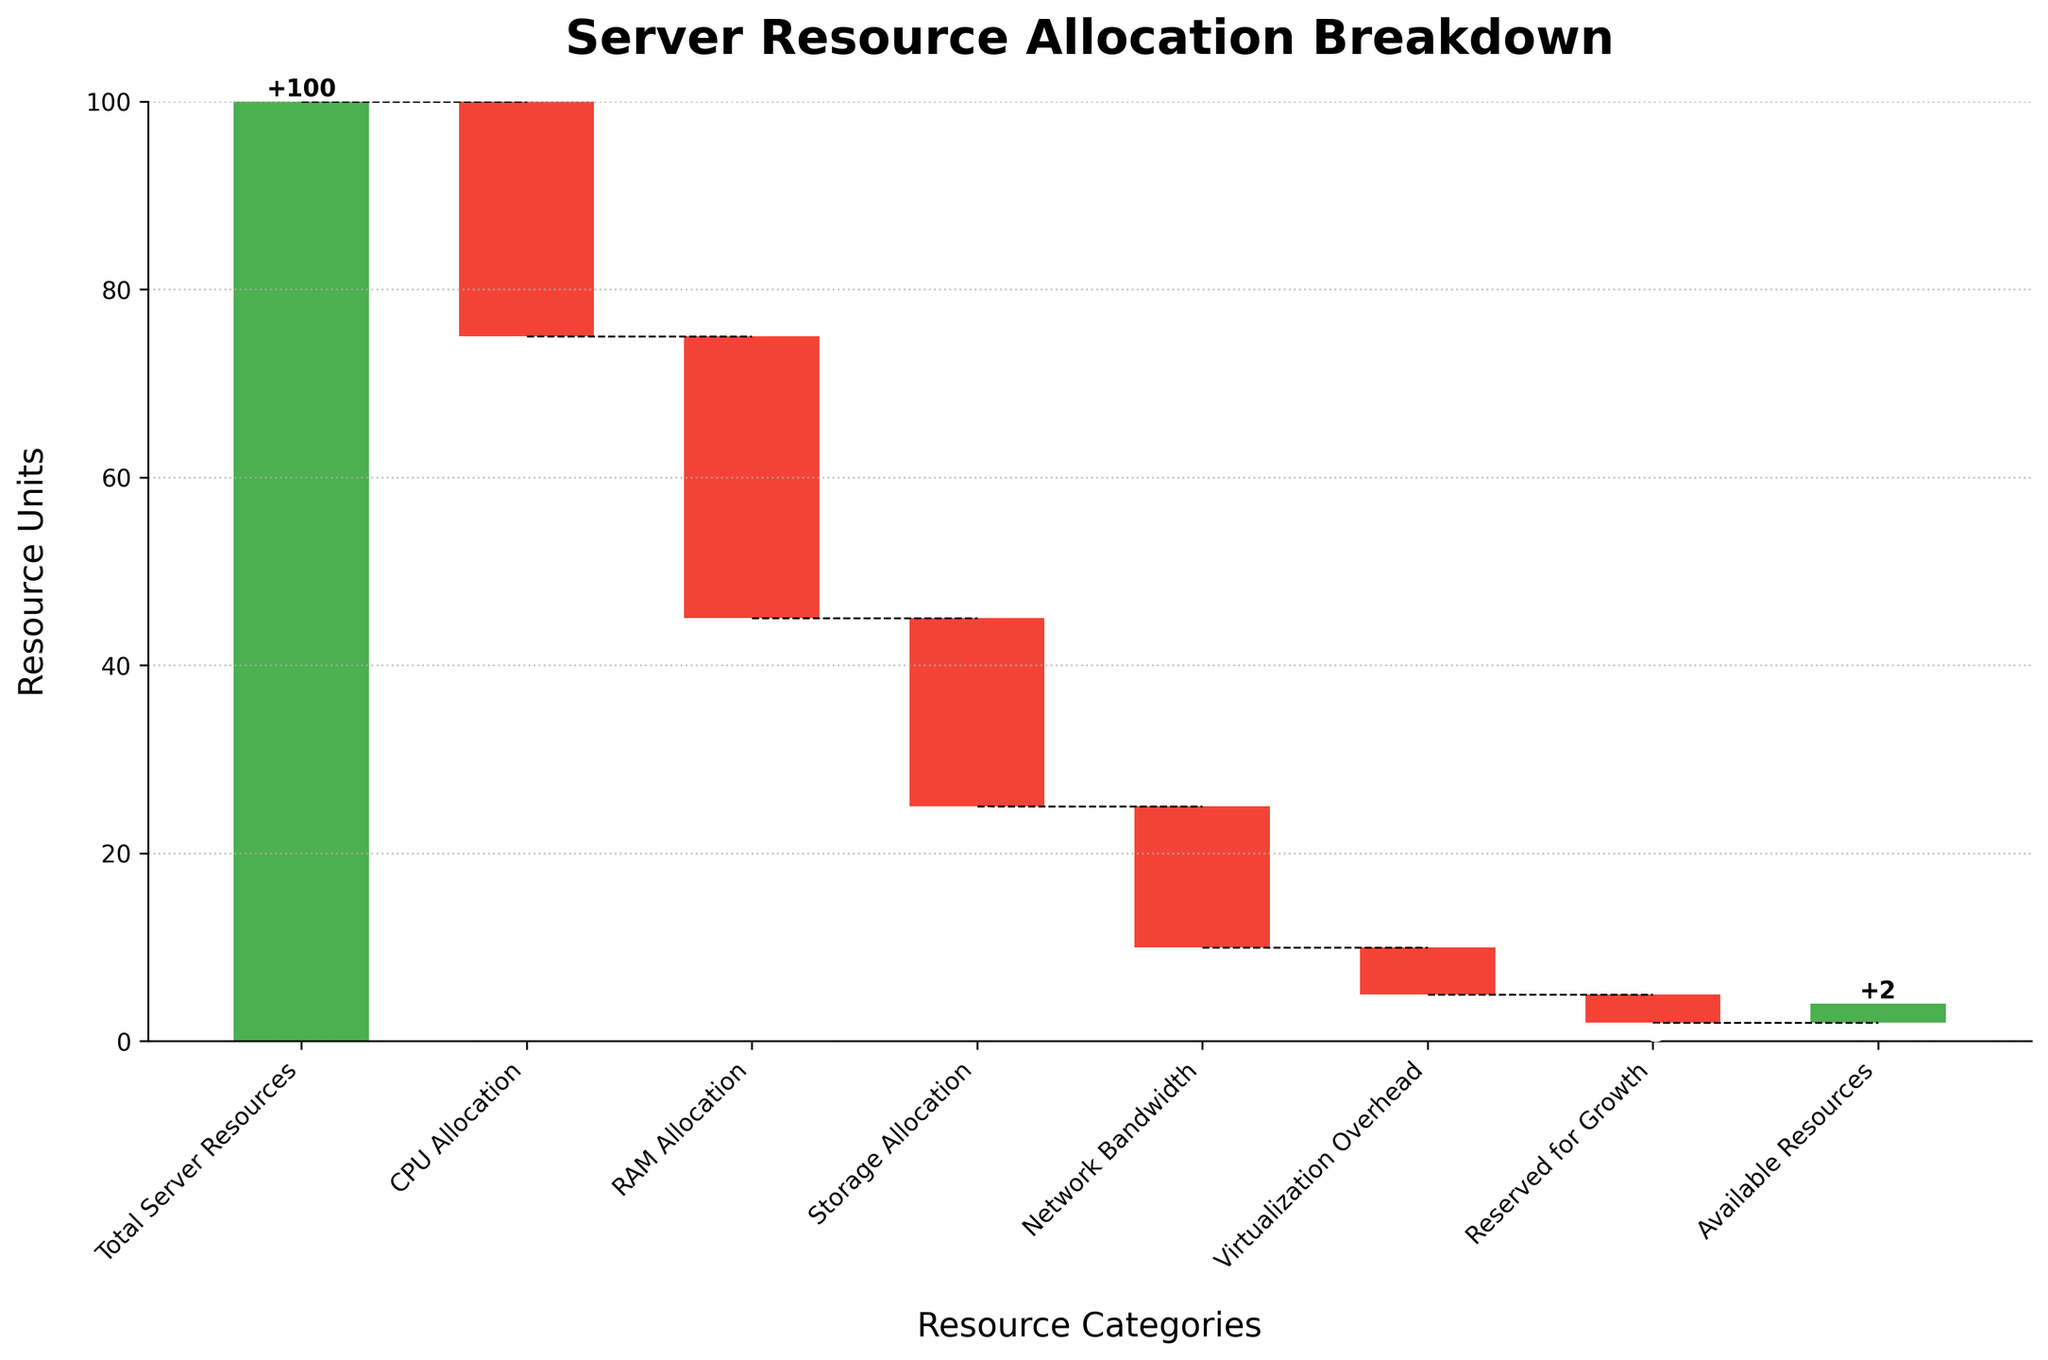What's the title of the figure? The title is typically located at the top of the figure and is intended to provide a summary of what the figure represents.
Answer: Server Resource Allocation Breakdown Which category has the smallest allocation value? The smallest allocation value can be identified by looking at the length of the bars colored red (indicating negative values) and finding the one that is most diminished.
Answer: Reserved for Growth What's the value of the CPU Allocation? The CPU allocation's value is depicted by the red bar labeled "CPU Allocation", and the precise value is marked on the bar.
Answer: -25 What are the total allocated resources minus the Reserved for Growth? First, sum all the negative allocation values except Reserved for Growth: CPU Allocation (-25), RAM Allocation (-30), Storage Allocation (-20), Network Bandwidth (-15), Virtualization Overhead (-5). Then calculate the sum: -25 - 30 - 20 - 15 - 5 = -95.
Answer: -95 What categories make up the Available Resources? Available Resources are the final cumulative value after all preceding categories' values are considered. Positive and negative allocations determine resources left. Summing the initial value with all allocations: 100 - 25 - 30 - 20 - 15 - 5 - 3.
Answer: All categories except Available Resources How do CPU Allocation and RAM Allocation compare? Compare the bars labeled "CPU Allocation" and "RAM Allocation" to see which is longer in the negative direction. The one with the larger negative value will be more extensive.
Answer: RAM Allocation is larger than CPU Allocation Which category decreases the server resources the most? Identify the category with the longest red bar, as a longer bar indicates a larger value in the negative direction. The label on this bar will correspond to the category with the most significant decrease.
Answer: RAM Allocation How much of the initial total server resources is allocated towards Storage Allocation and Network Bandwidth combined? Add the values for Storage Allocation (-20) and Network Bandwidth (-15): -20 + -15. The sum gives the total resources allocated to these two categories.
Answer: -35 What is the cumulative value after Virtualization Overhead is accounted for? Calculate the cumulative sum up to and including Virtualization Overhead: 100 (Initial) - 25 (CPU) - 30 (RAM) - 20 (Storage) - 15 (Network) - 5 (Virtualization).
Answer: 5 What's the difference between CPU Allocation and Reserved for Growth? Subtract the value of Reserved for Growth from the value of CPU Allocation: -25 - (-3).
Answer: -22 